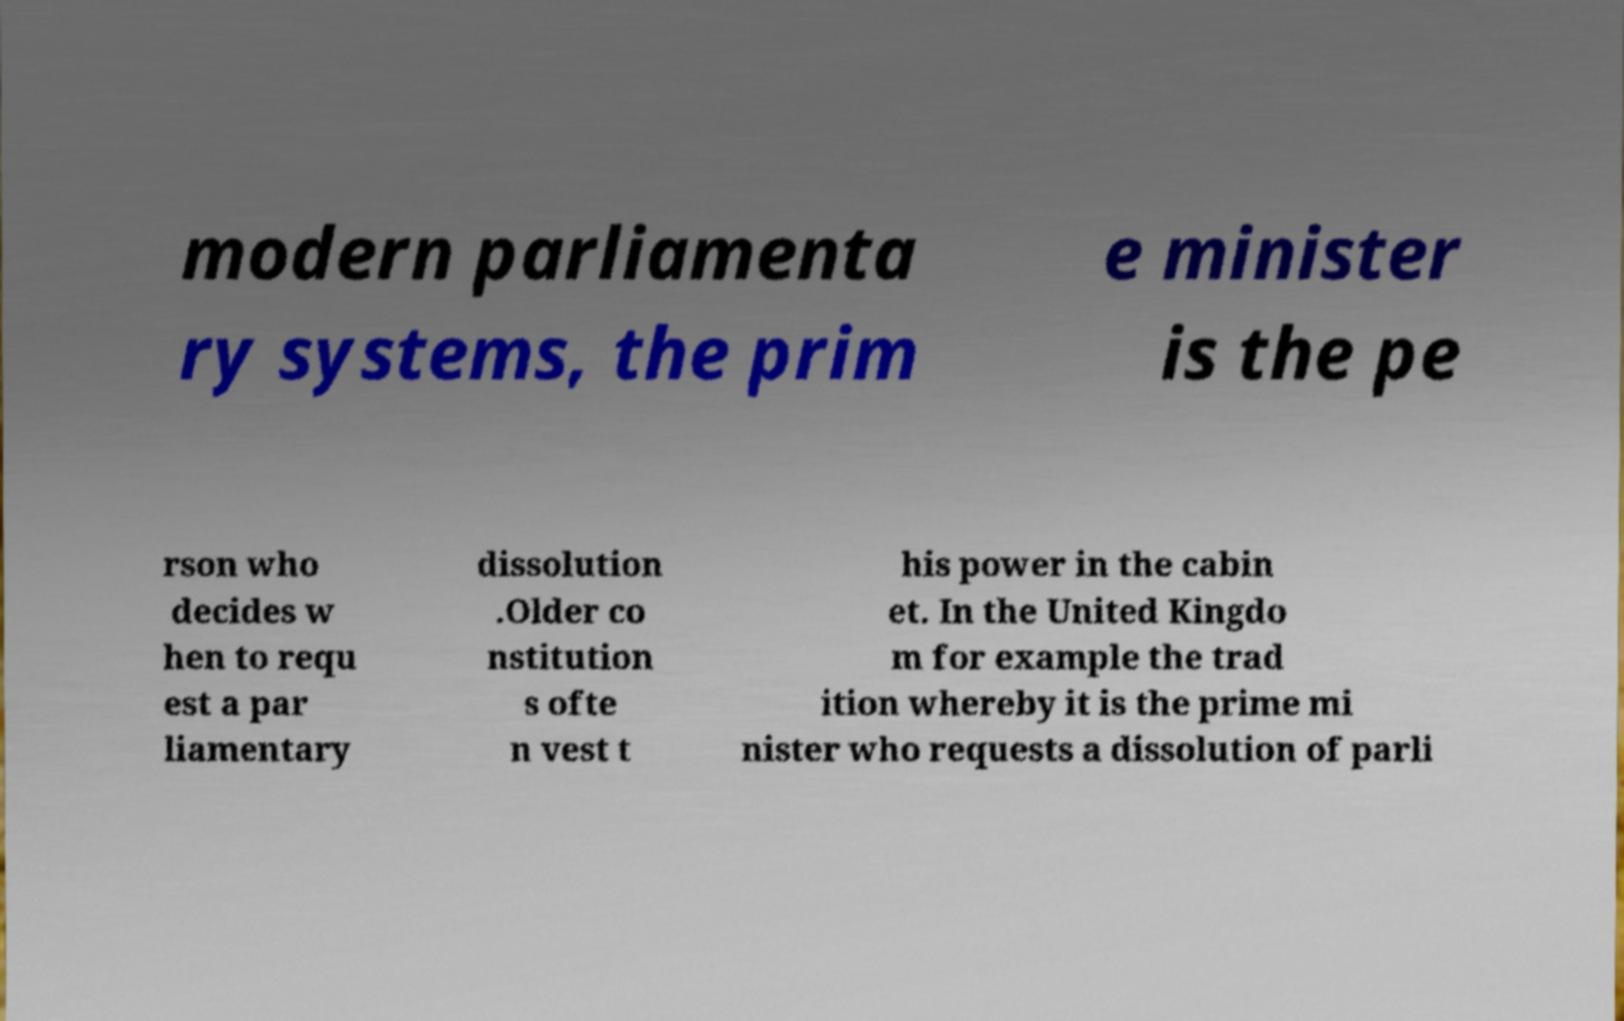There's text embedded in this image that I need extracted. Can you transcribe it verbatim? modern parliamenta ry systems, the prim e minister is the pe rson who decides w hen to requ est a par liamentary dissolution .Older co nstitution s ofte n vest t his power in the cabin et. In the United Kingdo m for example the trad ition whereby it is the prime mi nister who requests a dissolution of parli 